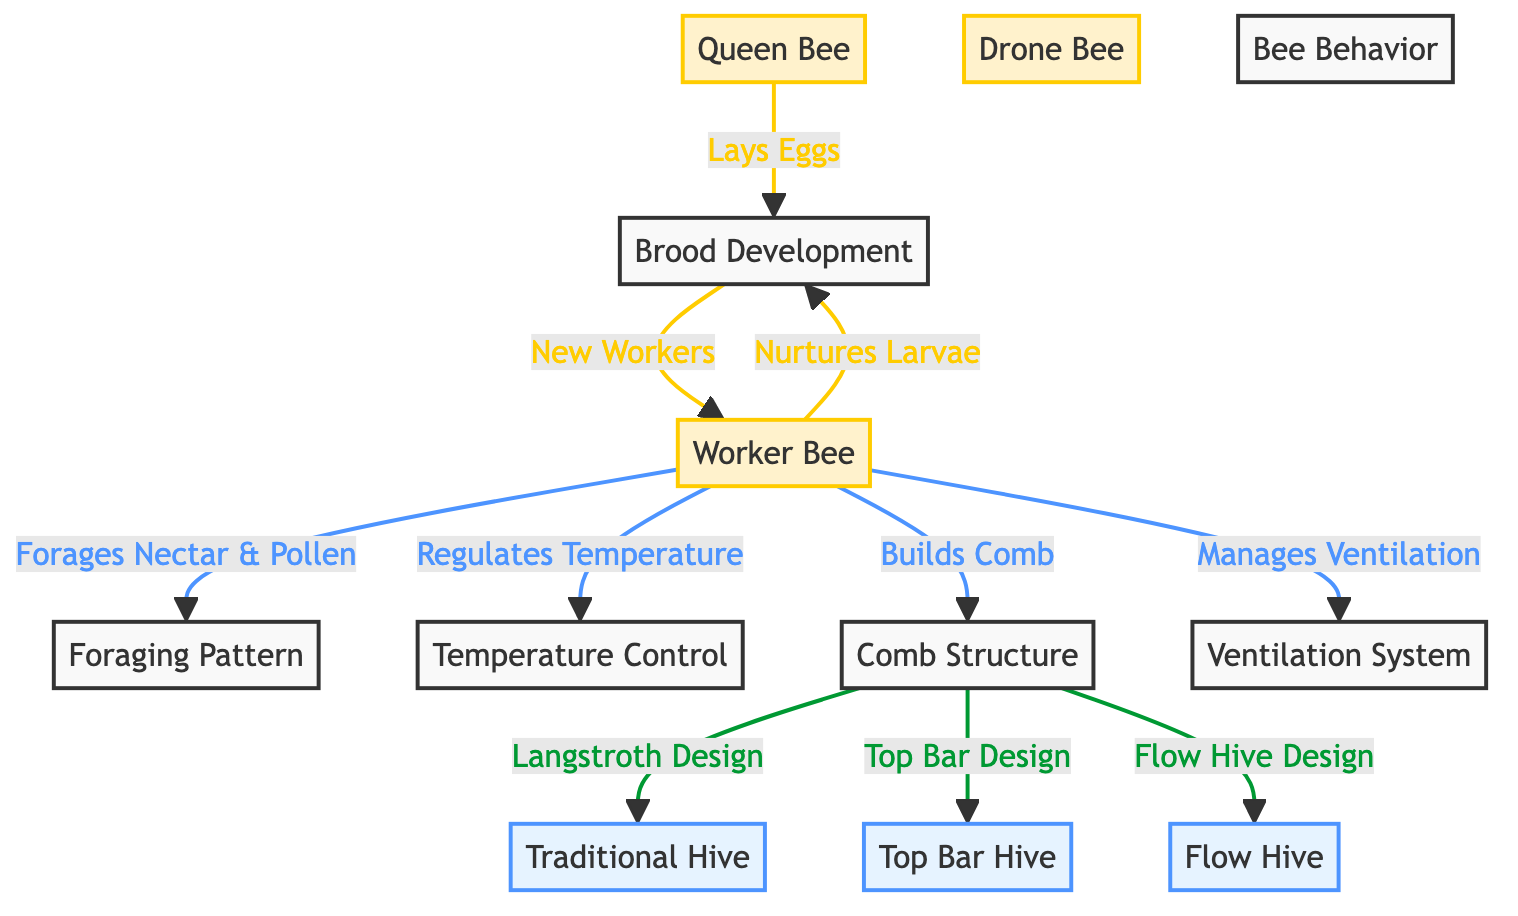What is the role of the Queen Bee? The Queen Bee's role is to lay eggs. This is indicated by the arrow from the Queen Bee to Brood Development, which signifies egg-laying activity.
Answer: Lays Eggs How do Worker Bees contribute to Brood Development? Worker Bees nurture larvae, as shown by the direct connection from Worker Bees to Brood Development. This indicates that Worker Bees help in the care of the eggs and young bees.
Answer: Nurtures Larvae Which hive design does the Comb Structure lead to? The Comb Structure leads to three different hive designs: Traditional Hive, Top Bar Hive, and Flow Hive. Each is directly connected to the Comb Structure, reflecting the design variations.
Answer: Traditional Hive, Top Bar Hive, Flow Hive What do Worker Bees regulate in the hive? Worker Bees regulate temperature and manage ventilation, as indicated by the two different arrows leading from Worker Bees to Temperature Control and Ventilation System.
Answer: Temperature and Ventilation What is the primary foraging activity of Worker Bees? Worker Bees forage for nectar and pollen, demonstrated by the arrow pointing from Worker Bees to Foraging Pattern. This indicates that their primary role involves collecting food resources.
Answer: Forages Nectar & Pollen How many different types of hives are mentioned in the diagram? There are three types of hive designs mentioned in the diagram: Traditional Hive, Top Bar Hive, and Flow Hive. These are the nodes branching from the Comb Structure.
Answer: Three What is the purpose of the Comb Structure in relation to the hive? The Comb Structure allows for different hive designs, indicated by the connections it makes to Traditional Hive, Top Bar Hive, and Flow Hive. It serves as a basis for these variations.
Answer: Hive Design How does the Worker Bee system contribute to temperature control? Worker Bees are responsible for regulating temperature indicated by the direct connection to Temperature Control, suggesting they perform actions necessary to maintain a suitable environment within the hive.
Answer: Regulates Temperature What do the arrows in the diagram represent? The arrows represent the relationships and actions between the various components of bee life and hive management, such as egg-laying, nurturing, foraging, and design elements.
Answer: Relationships and Actions 